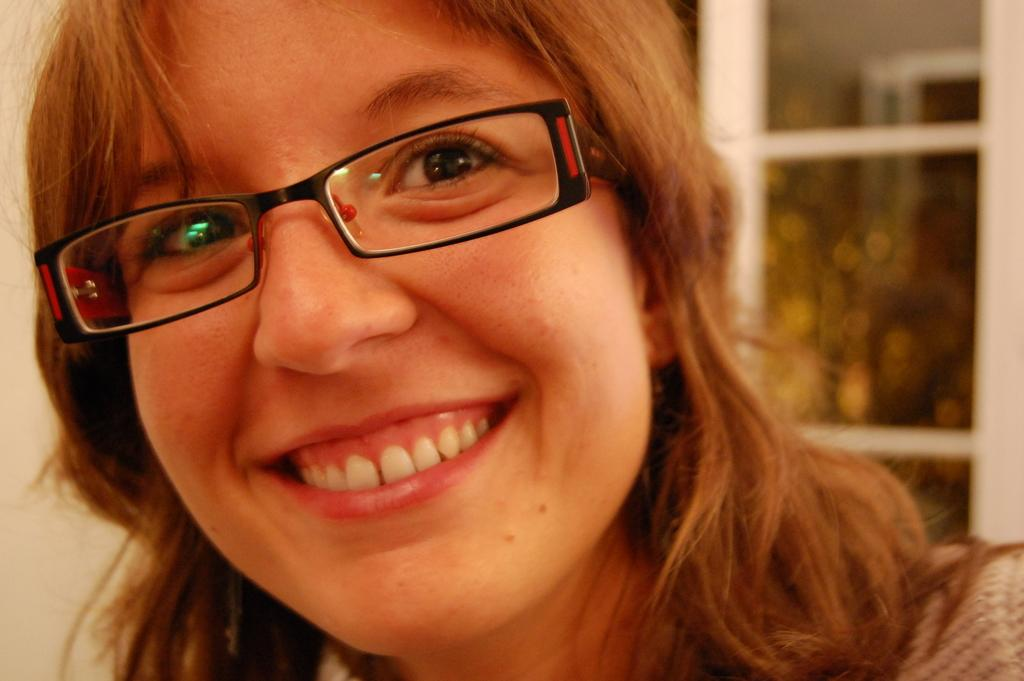What is the main subject of the image? There is a close-up picture of a woman in the image. Can you describe the woman's appearance? The woman is wearing clothes and spectacles. What expression does the woman have? The woman is smiling. How would you describe the background of the image? The background of the image is slightly blurred. What type of hen can be seen in the woman's hand in the image? There is no hen present in the image; it features a close-up picture of a woman wearing spectacles and smiling. What root vegetable is visible in the woman's hair in the image? There is no root vegetable present in the woman's hair in the image. 